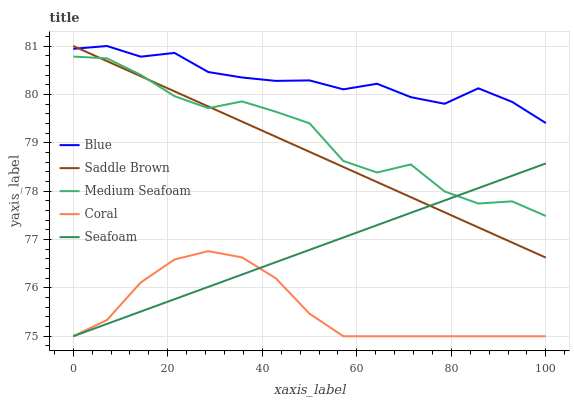Does Coral have the minimum area under the curve?
Answer yes or no. Yes. Does Blue have the maximum area under the curve?
Answer yes or no. Yes. Does Seafoam have the minimum area under the curve?
Answer yes or no. No. Does Seafoam have the maximum area under the curve?
Answer yes or no. No. Is Saddle Brown the smoothest?
Answer yes or no. Yes. Is Medium Seafoam the roughest?
Answer yes or no. Yes. Is Coral the smoothest?
Answer yes or no. No. Is Coral the roughest?
Answer yes or no. No. Does Coral have the lowest value?
Answer yes or no. Yes. Does Saddle Brown have the lowest value?
Answer yes or no. No. Does Saddle Brown have the highest value?
Answer yes or no. Yes. Does Seafoam have the highest value?
Answer yes or no. No. Is Coral less than Blue?
Answer yes or no. Yes. Is Blue greater than Seafoam?
Answer yes or no. Yes. Does Medium Seafoam intersect Saddle Brown?
Answer yes or no. Yes. Is Medium Seafoam less than Saddle Brown?
Answer yes or no. No. Is Medium Seafoam greater than Saddle Brown?
Answer yes or no. No. Does Coral intersect Blue?
Answer yes or no. No. 